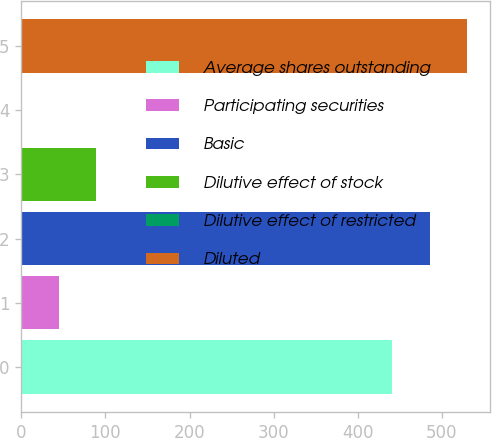<chart> <loc_0><loc_0><loc_500><loc_500><bar_chart><fcel>Average shares outstanding<fcel>Participating securities<fcel>Basic<fcel>Dilutive effect of stock<fcel>Dilutive effect of restricted<fcel>Diluted<nl><fcel>441.3<fcel>44.72<fcel>485.92<fcel>89.34<fcel>0.1<fcel>530.54<nl></chart> 